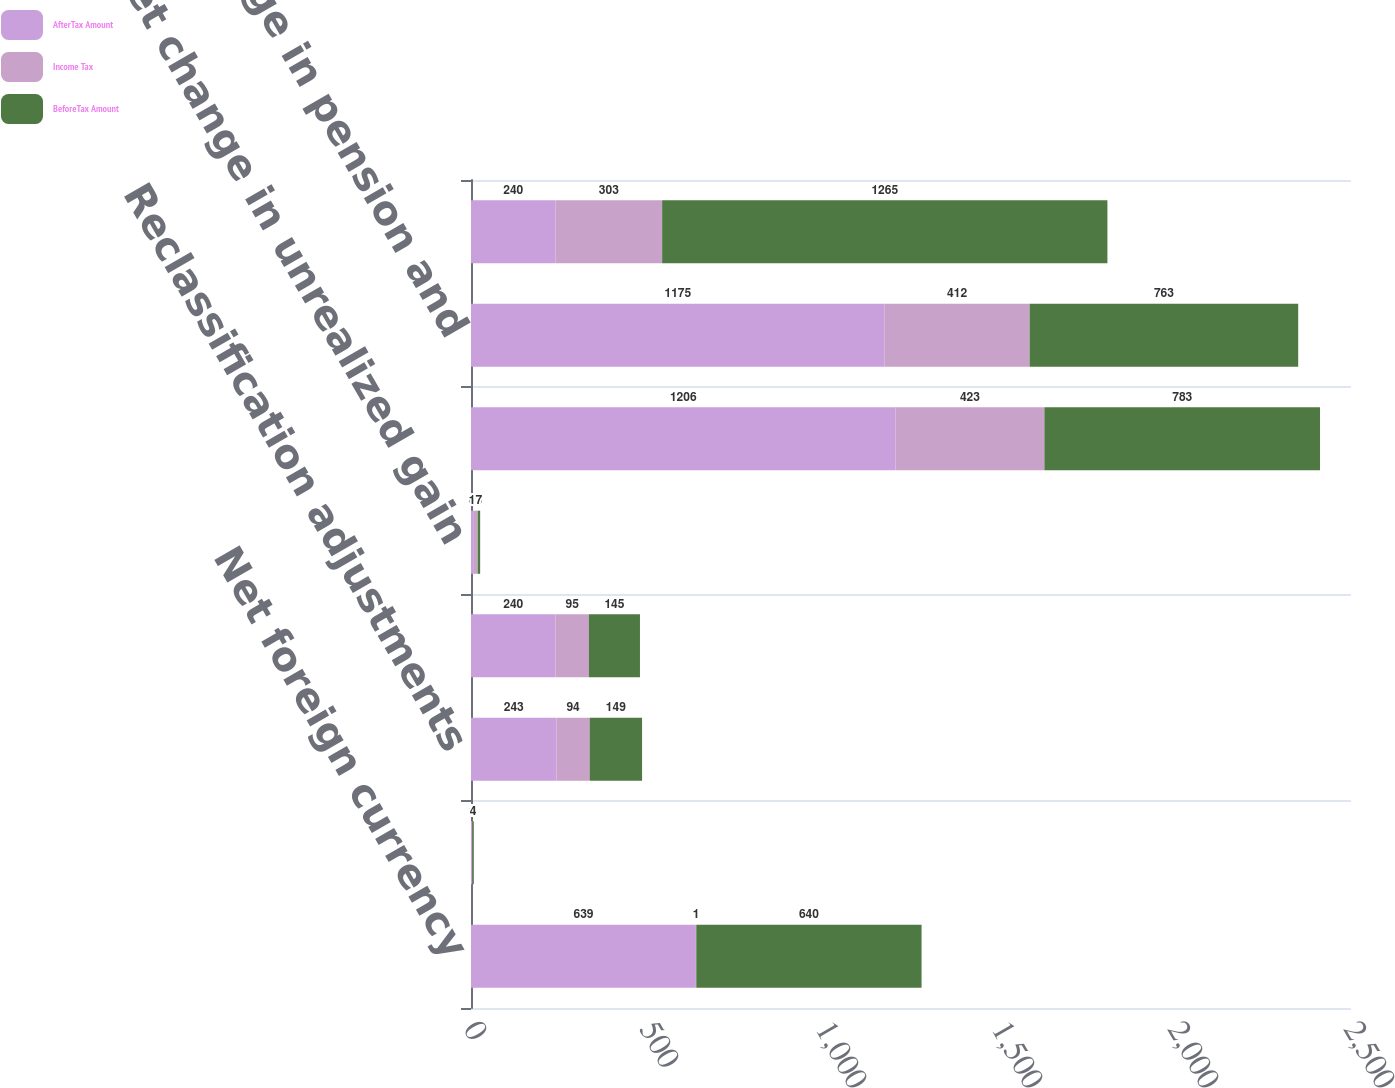Convert chart. <chart><loc_0><loc_0><loc_500><loc_500><stacked_bar_chart><ecel><fcel>Net foreign currency<fcel>Unrealized gains (losses)<fcel>Reclassification adjustments<fcel>Net gain (loss) on derivatives<fcel>Net change in unrealized gain<fcel>Net pension and other benefits<fcel>Net change in pension and<fcel>Other comprehensive income<nl><fcel>AfterTax Amount<fcel>639<fcel>3<fcel>243<fcel>240<fcel>6<fcel>1206<fcel>1175<fcel>240<nl><fcel>Income Tax<fcel>1<fcel>1<fcel>94<fcel>95<fcel>13<fcel>423<fcel>412<fcel>303<nl><fcel>BeforeTax Amount<fcel>640<fcel>4<fcel>149<fcel>145<fcel>7<fcel>783<fcel>763<fcel>1265<nl></chart> 